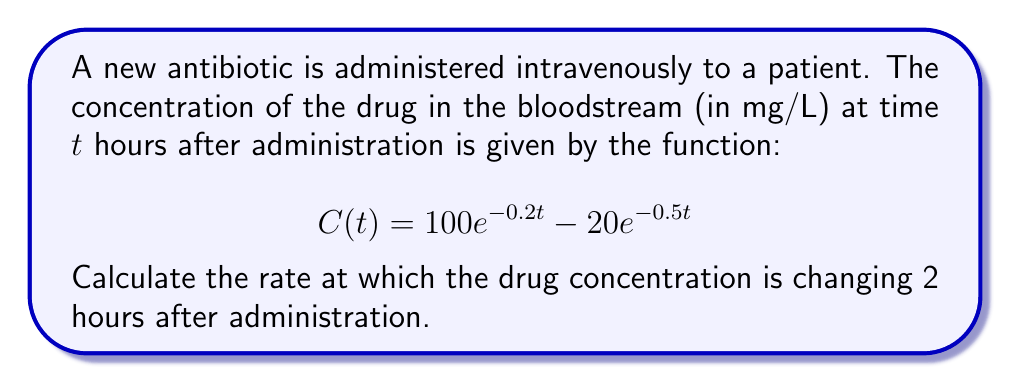Give your solution to this math problem. To solve this problem, we need to follow these steps:

1) The rate of change of drug concentration is given by the derivative of the concentration function C(t) with respect to time.

2) Let's find the derivative of C(t):

   $$\frac{d}{dt}C(t) = \frac{d}{dt}(100e^{-0.2t} - 20e^{-0.5t})$$

3) Using the chain rule, we get:

   $$C'(t) = 100(-0.2)e^{-0.2t} - 20(-0.5)e^{-0.5t}$$
   $$C'(t) = -20e^{-0.2t} + 10e^{-0.5t}$$

4) Now, we need to evaluate this at t = 2 hours:

   $$C'(2) = -20e^{-0.2(2)} + 10e^{-0.5(2)}$$
   $$C'(2) = -20e^{-0.4} + 10e^{-1}$$

5) Let's calculate these values:

   $$e^{-0.4} \approx 0.6703$$
   $$e^{-1} \approx 0.3679$$

6) Substituting these values:

   $$C'(2) = -20(0.6703) + 10(0.3679)$$
   $$C'(2) = -13.406 + 3.679$$
   $$C'(2) = -9.727$$

7) The negative value indicates that the concentration is decreasing.
Answer: $-9.727$ mg/L/hour 